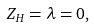Convert formula to latex. <formula><loc_0><loc_0><loc_500><loc_500>Z _ { H } = \lambda = 0 ,</formula> 